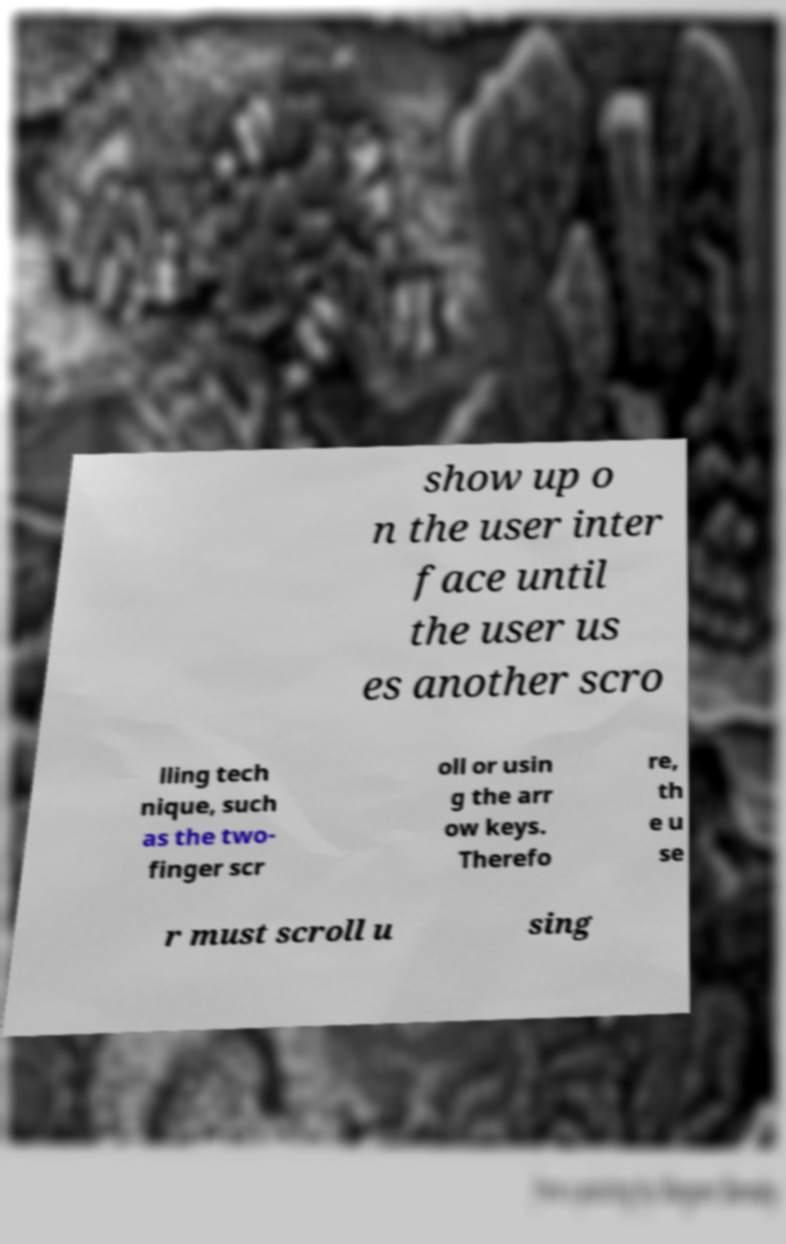What messages or text are displayed in this image? I need them in a readable, typed format. show up o n the user inter face until the user us es another scro lling tech nique, such as the two- finger scr oll or usin g the arr ow keys. Therefo re, th e u se r must scroll u sing 